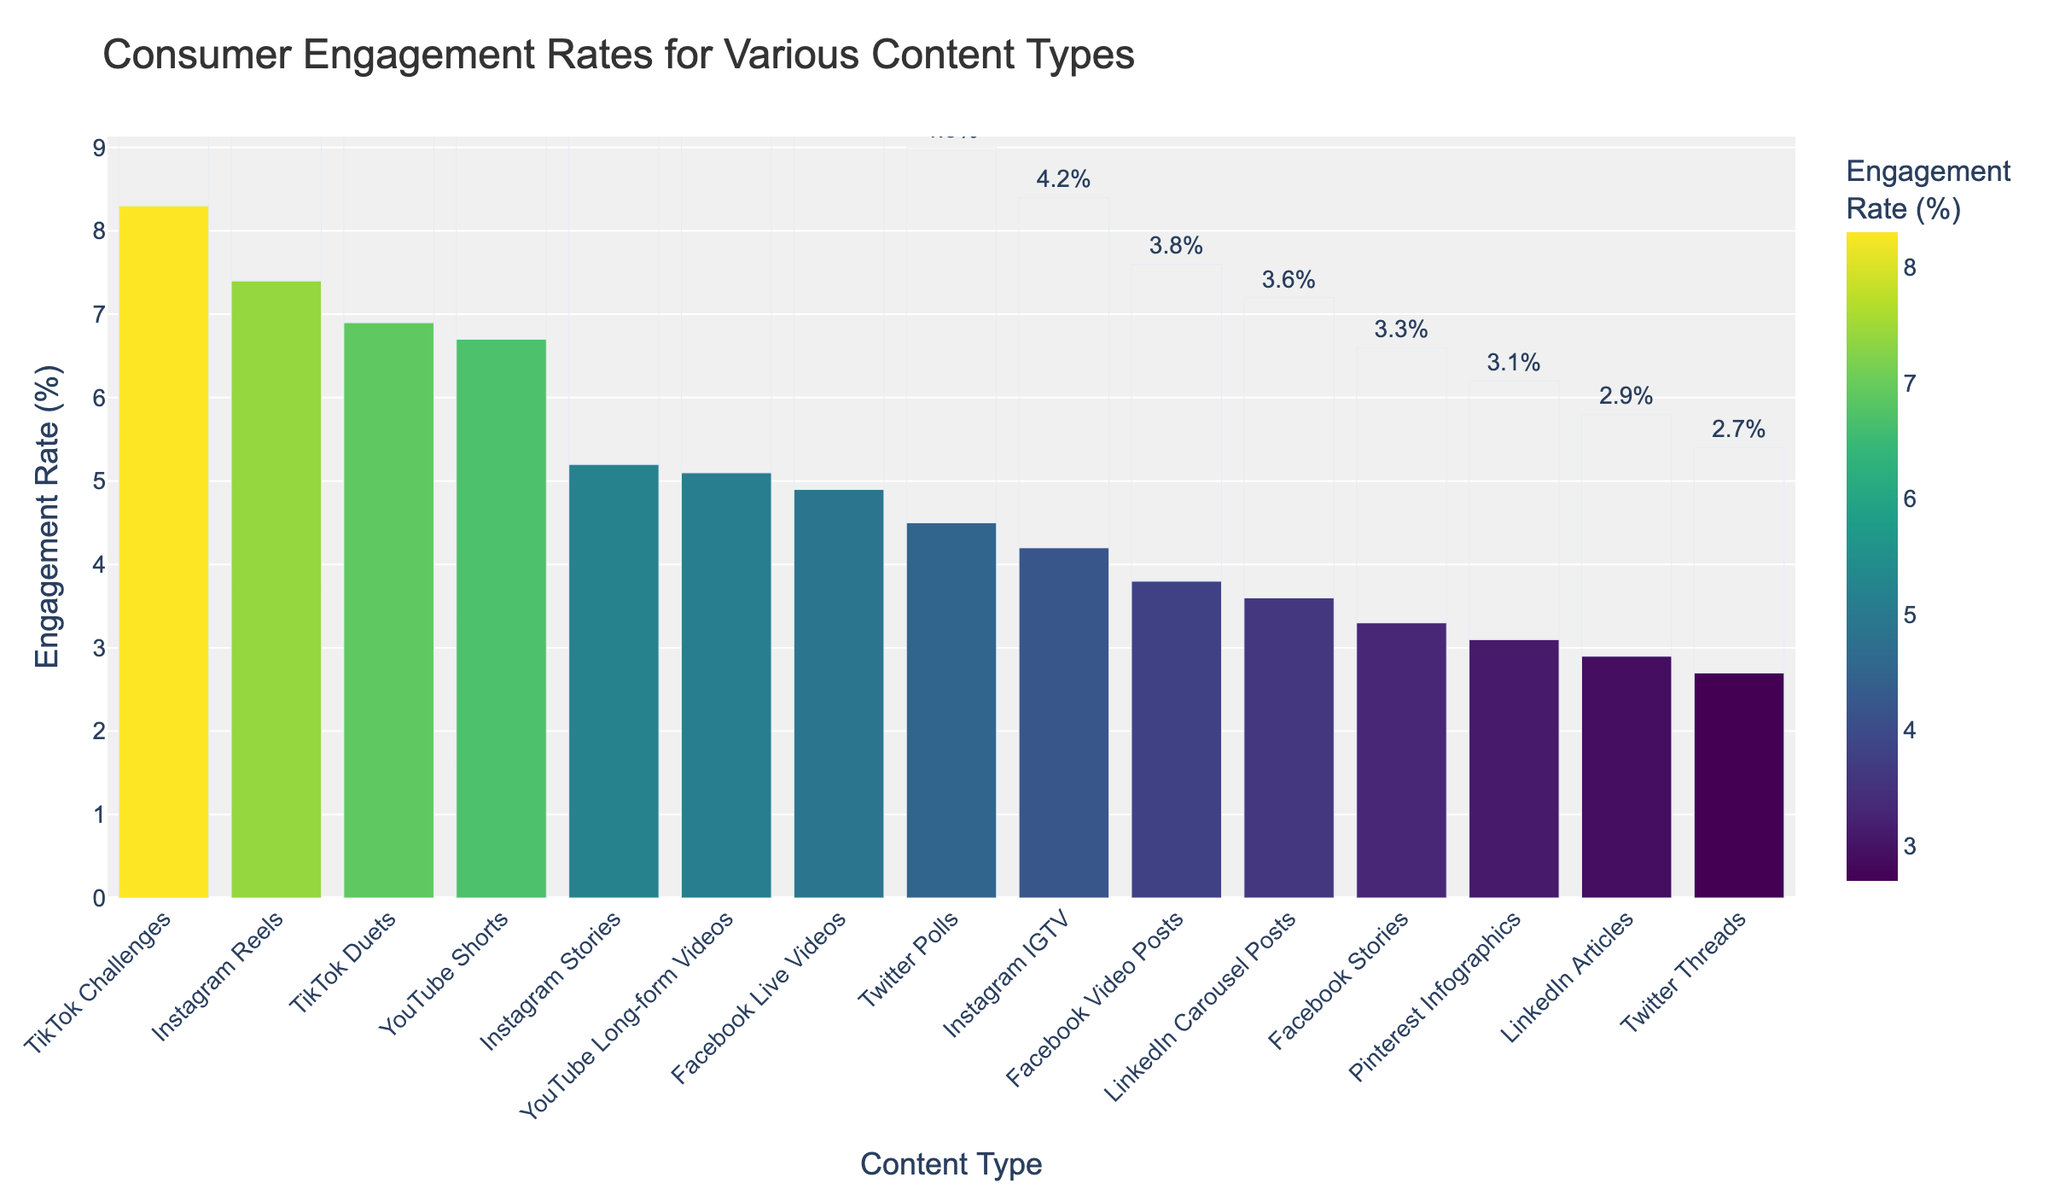Which content type has the highest engagement rate? Look at the bar with the maximum height to identify the content type with the highest engagement rate. "TikTok Challenges" has the highest bar at 8.3%.
Answer: TikTok Challenges Which content type has the lowest engagement rate? Look at the bar with the minimum height to identify the content type with the lowest engagement rate. "Twitter Threads" has the lowest bar at 2.7%.
Answer: Twitter Threads How much higher is the engagement rate of Instagram Reels compared to Facebook Video Posts? Find the engagement rates of both content types: Instagram Reels (7.4%), Facebook Video Posts (3.8%). Subtract the engagement rate of Facebook Video Posts from Instagram Reels. 7.4% - 3.8% = 3.6%.
Answer: 3.6% Which has a higher engagement rate: LinkedIn Articles or Facebook Stories? Compare the heights of the bars representing LinkedIn Articles (2.9%) and Facebook Stories (3.3%). Facebook Stories has a higher engagement rate.
Answer: Facebook Stories What's the total engagement rate for Instagram Stories, Instagram Reels, and Instagram IGTV combined? Add the engagement rates of Instagram Stories (5.2%), Instagram Reels (7.4%), and Instagram IGTV (4.2%). 5.2% + 7.4% + 4.2% = 16.8%.
Answer: 16.8% Which three content types have engagement rates above 6%? Identify bars with engagement rates higher than 6%. These are TikTok Challenges (8.3%), YouTube Shorts (6.7%), Instagram Reels (7.4%), and TikTok Duets (6.9%).
Answer: TikTok Challenges, YouTube Shorts, Instagram Reels, TikTok Duets Are YouTube Long-form Videos or Facebook Live Videos more engaging? Compare the engagement rates of YouTube Long-form Videos (5.1%) and Facebook Live Videos (4.9%). YouTube Long-form Videos have a slightly higher engagement rate.
Answer: YouTube Long-form Videos What's the average engagement rate for the four types of content with the highest engagement rates? Identify the four highest rates: TikTok Challenges (8.3%), Instagram Reels (7.4%), TikTok Duets (6.9%), YouTube Shorts (6.7%). Calculate their average: (8.3% + 7.4% + 6.9% + 6.7%) / 4 = 7.325%.
Answer: 7.325% Which platform—Instagram or Facebook—has a higher overall engagement rate, considering all content types listed? Calculate the sum of engagement rates for all Instagram content (Instagram Stories 5.2%, Instagram Reels 7.4%, and Instagram IGTV 4.2%) and Facebook content (Facebook Video Posts 3.8%, Facebook Live Videos 4.9%, and Facebook Stories 3.3%). Compare the sums: Instagram total is 5.2 + 7.4 + 4.2 = 16.8%; Facebook total is 3.8 + 4.9 + 3.3 = 12.0%. Instagram has a higher overall engagement rate.
Answer: Instagram 